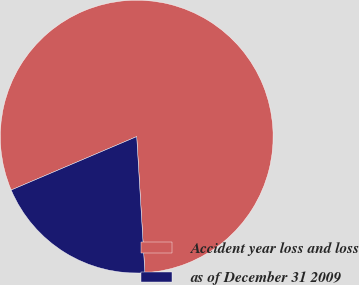<chart> <loc_0><loc_0><loc_500><loc_500><pie_chart><fcel>Accident year loss and loss<fcel>as of December 31 2009<nl><fcel>80.45%<fcel>19.55%<nl></chart> 